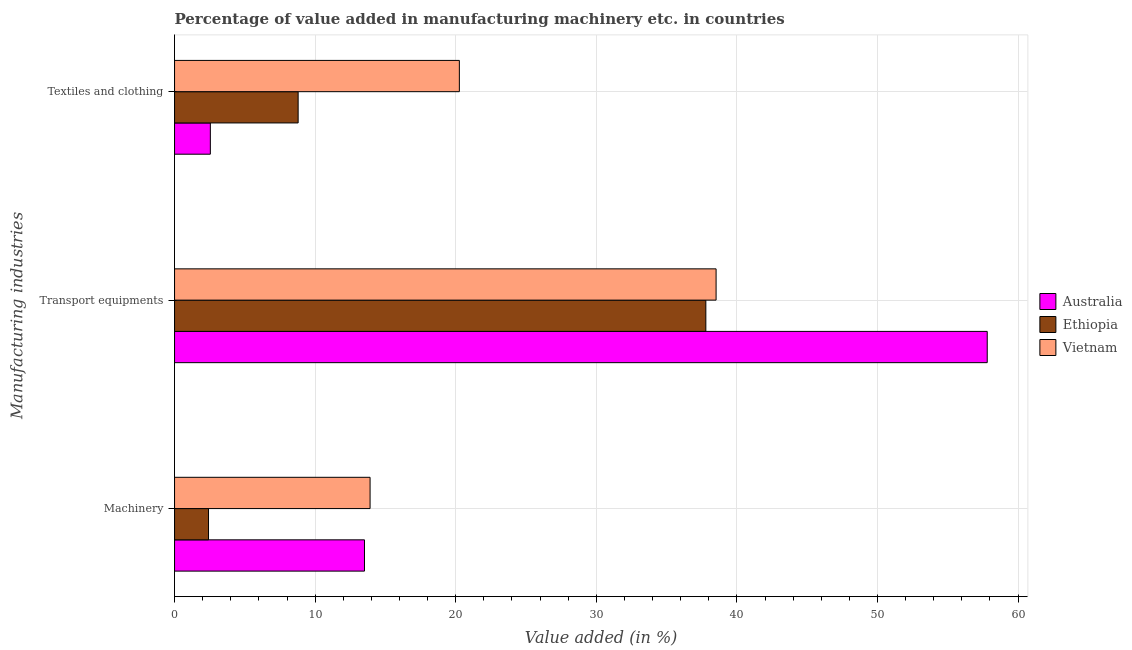How many groups of bars are there?
Keep it short and to the point. 3. What is the label of the 1st group of bars from the top?
Offer a very short reply. Textiles and clothing. What is the value added in manufacturing transport equipments in Australia?
Ensure brevity in your answer.  57.81. Across all countries, what is the maximum value added in manufacturing textile and clothing?
Your answer should be very brief. 20.26. Across all countries, what is the minimum value added in manufacturing textile and clothing?
Provide a succinct answer. 2.55. In which country was the value added in manufacturing textile and clothing maximum?
Make the answer very short. Vietnam. In which country was the value added in manufacturing textile and clothing minimum?
Make the answer very short. Australia. What is the total value added in manufacturing textile and clothing in the graph?
Your answer should be compact. 31.6. What is the difference between the value added in manufacturing transport equipments in Vietnam and that in Australia?
Ensure brevity in your answer.  -19.29. What is the difference between the value added in manufacturing textile and clothing in Vietnam and the value added in manufacturing machinery in Ethiopia?
Make the answer very short. 17.84. What is the average value added in manufacturing textile and clothing per country?
Your answer should be very brief. 10.53. What is the difference between the value added in manufacturing machinery and value added in manufacturing textile and clothing in Ethiopia?
Keep it short and to the point. -6.38. In how many countries, is the value added in manufacturing machinery greater than 32 %?
Your answer should be compact. 0. What is the ratio of the value added in manufacturing machinery in Australia to that in Vietnam?
Make the answer very short. 0.97. Is the value added in manufacturing machinery in Ethiopia less than that in Australia?
Give a very brief answer. Yes. What is the difference between the highest and the second highest value added in manufacturing machinery?
Make the answer very short. 0.4. What is the difference between the highest and the lowest value added in manufacturing machinery?
Make the answer very short. 11.49. In how many countries, is the value added in manufacturing transport equipments greater than the average value added in manufacturing transport equipments taken over all countries?
Keep it short and to the point. 1. Is the sum of the value added in manufacturing transport equipments in Vietnam and Australia greater than the maximum value added in manufacturing textile and clothing across all countries?
Provide a succinct answer. Yes. What does the 2nd bar from the top in Transport equipments represents?
Provide a short and direct response. Ethiopia. What does the 2nd bar from the bottom in Textiles and clothing represents?
Keep it short and to the point. Ethiopia. How many bars are there?
Your answer should be compact. 9. What is the difference between two consecutive major ticks on the X-axis?
Your answer should be very brief. 10. Does the graph contain any zero values?
Make the answer very short. No. Where does the legend appear in the graph?
Offer a very short reply. Center right. How many legend labels are there?
Your answer should be very brief. 3. What is the title of the graph?
Your answer should be very brief. Percentage of value added in manufacturing machinery etc. in countries. What is the label or title of the X-axis?
Make the answer very short. Value added (in %). What is the label or title of the Y-axis?
Keep it short and to the point. Manufacturing industries. What is the Value added (in %) in Australia in Machinery?
Your response must be concise. 13.51. What is the Value added (in %) in Ethiopia in Machinery?
Offer a very short reply. 2.42. What is the Value added (in %) in Vietnam in Machinery?
Provide a short and direct response. 13.91. What is the Value added (in %) in Australia in Transport equipments?
Ensure brevity in your answer.  57.81. What is the Value added (in %) in Ethiopia in Transport equipments?
Offer a very short reply. 37.79. What is the Value added (in %) of Vietnam in Transport equipments?
Ensure brevity in your answer.  38.52. What is the Value added (in %) of Australia in Textiles and clothing?
Offer a very short reply. 2.55. What is the Value added (in %) of Ethiopia in Textiles and clothing?
Give a very brief answer. 8.79. What is the Value added (in %) in Vietnam in Textiles and clothing?
Make the answer very short. 20.26. Across all Manufacturing industries, what is the maximum Value added (in %) in Australia?
Make the answer very short. 57.81. Across all Manufacturing industries, what is the maximum Value added (in %) of Ethiopia?
Your answer should be compact. 37.79. Across all Manufacturing industries, what is the maximum Value added (in %) in Vietnam?
Give a very brief answer. 38.52. Across all Manufacturing industries, what is the minimum Value added (in %) in Australia?
Offer a very short reply. 2.55. Across all Manufacturing industries, what is the minimum Value added (in %) of Ethiopia?
Make the answer very short. 2.42. Across all Manufacturing industries, what is the minimum Value added (in %) of Vietnam?
Your answer should be compact. 13.91. What is the total Value added (in %) in Australia in the graph?
Your answer should be very brief. 73.86. What is the total Value added (in %) in Ethiopia in the graph?
Keep it short and to the point. 49. What is the total Value added (in %) of Vietnam in the graph?
Keep it short and to the point. 72.69. What is the difference between the Value added (in %) of Australia in Machinery and that in Transport equipments?
Provide a succinct answer. -44.3. What is the difference between the Value added (in %) in Ethiopia in Machinery and that in Transport equipments?
Provide a short and direct response. -35.38. What is the difference between the Value added (in %) in Vietnam in Machinery and that in Transport equipments?
Offer a very short reply. -24.61. What is the difference between the Value added (in %) of Australia in Machinery and that in Textiles and clothing?
Provide a short and direct response. 10.96. What is the difference between the Value added (in %) in Ethiopia in Machinery and that in Textiles and clothing?
Give a very brief answer. -6.38. What is the difference between the Value added (in %) in Vietnam in Machinery and that in Textiles and clothing?
Your answer should be very brief. -6.35. What is the difference between the Value added (in %) of Australia in Transport equipments and that in Textiles and clothing?
Provide a succinct answer. 55.26. What is the difference between the Value added (in %) of Ethiopia in Transport equipments and that in Textiles and clothing?
Your response must be concise. 29. What is the difference between the Value added (in %) of Vietnam in Transport equipments and that in Textiles and clothing?
Provide a succinct answer. 18.26. What is the difference between the Value added (in %) in Australia in Machinery and the Value added (in %) in Ethiopia in Transport equipments?
Offer a terse response. -24.28. What is the difference between the Value added (in %) in Australia in Machinery and the Value added (in %) in Vietnam in Transport equipments?
Make the answer very short. -25.01. What is the difference between the Value added (in %) in Ethiopia in Machinery and the Value added (in %) in Vietnam in Transport equipments?
Your response must be concise. -36.1. What is the difference between the Value added (in %) in Australia in Machinery and the Value added (in %) in Ethiopia in Textiles and clothing?
Provide a succinct answer. 4.72. What is the difference between the Value added (in %) of Australia in Machinery and the Value added (in %) of Vietnam in Textiles and clothing?
Make the answer very short. -6.75. What is the difference between the Value added (in %) of Ethiopia in Machinery and the Value added (in %) of Vietnam in Textiles and clothing?
Make the answer very short. -17.84. What is the difference between the Value added (in %) of Australia in Transport equipments and the Value added (in %) of Ethiopia in Textiles and clothing?
Make the answer very short. 49.02. What is the difference between the Value added (in %) of Australia in Transport equipments and the Value added (in %) of Vietnam in Textiles and clothing?
Offer a terse response. 37.55. What is the difference between the Value added (in %) of Ethiopia in Transport equipments and the Value added (in %) of Vietnam in Textiles and clothing?
Provide a succinct answer. 17.53. What is the average Value added (in %) of Australia per Manufacturing industries?
Provide a succinct answer. 24.62. What is the average Value added (in %) in Ethiopia per Manufacturing industries?
Make the answer very short. 16.33. What is the average Value added (in %) in Vietnam per Manufacturing industries?
Your answer should be compact. 24.23. What is the difference between the Value added (in %) of Australia and Value added (in %) of Ethiopia in Machinery?
Offer a very short reply. 11.09. What is the difference between the Value added (in %) of Australia and Value added (in %) of Vietnam in Machinery?
Provide a short and direct response. -0.4. What is the difference between the Value added (in %) of Ethiopia and Value added (in %) of Vietnam in Machinery?
Offer a very short reply. -11.49. What is the difference between the Value added (in %) in Australia and Value added (in %) in Ethiopia in Transport equipments?
Keep it short and to the point. 20.02. What is the difference between the Value added (in %) of Australia and Value added (in %) of Vietnam in Transport equipments?
Make the answer very short. 19.29. What is the difference between the Value added (in %) in Ethiopia and Value added (in %) in Vietnam in Transport equipments?
Your response must be concise. -0.73. What is the difference between the Value added (in %) of Australia and Value added (in %) of Ethiopia in Textiles and clothing?
Make the answer very short. -6.25. What is the difference between the Value added (in %) in Australia and Value added (in %) in Vietnam in Textiles and clothing?
Give a very brief answer. -17.71. What is the difference between the Value added (in %) in Ethiopia and Value added (in %) in Vietnam in Textiles and clothing?
Make the answer very short. -11.47. What is the ratio of the Value added (in %) of Australia in Machinery to that in Transport equipments?
Make the answer very short. 0.23. What is the ratio of the Value added (in %) of Ethiopia in Machinery to that in Transport equipments?
Offer a very short reply. 0.06. What is the ratio of the Value added (in %) in Vietnam in Machinery to that in Transport equipments?
Ensure brevity in your answer.  0.36. What is the ratio of the Value added (in %) in Australia in Machinery to that in Textiles and clothing?
Your answer should be very brief. 5.31. What is the ratio of the Value added (in %) of Ethiopia in Machinery to that in Textiles and clothing?
Provide a succinct answer. 0.27. What is the ratio of the Value added (in %) of Vietnam in Machinery to that in Textiles and clothing?
Provide a short and direct response. 0.69. What is the ratio of the Value added (in %) in Australia in Transport equipments to that in Textiles and clothing?
Provide a short and direct response. 22.71. What is the ratio of the Value added (in %) of Ethiopia in Transport equipments to that in Textiles and clothing?
Ensure brevity in your answer.  4.3. What is the ratio of the Value added (in %) in Vietnam in Transport equipments to that in Textiles and clothing?
Provide a succinct answer. 1.9. What is the difference between the highest and the second highest Value added (in %) in Australia?
Make the answer very short. 44.3. What is the difference between the highest and the second highest Value added (in %) of Ethiopia?
Your response must be concise. 29. What is the difference between the highest and the second highest Value added (in %) in Vietnam?
Your response must be concise. 18.26. What is the difference between the highest and the lowest Value added (in %) in Australia?
Your response must be concise. 55.26. What is the difference between the highest and the lowest Value added (in %) of Ethiopia?
Give a very brief answer. 35.38. What is the difference between the highest and the lowest Value added (in %) of Vietnam?
Offer a terse response. 24.61. 